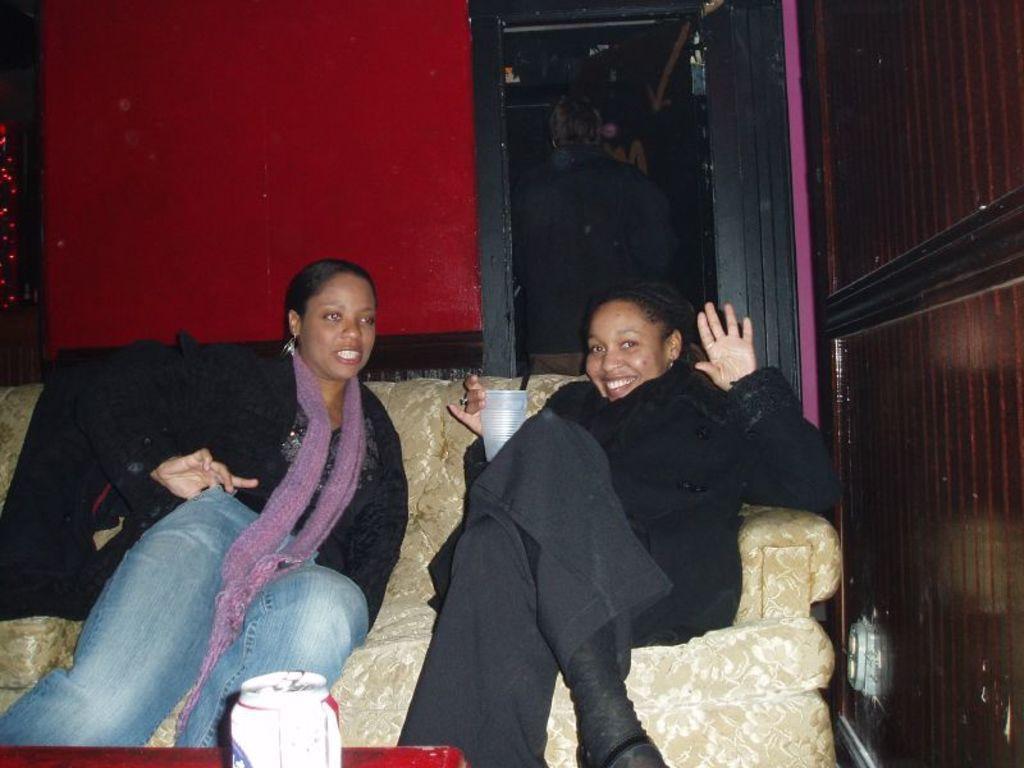Please provide a concise description of this image. In this image, there are two women sitting on a couch. At the bottom of the image, I can see a tin on an object. Behind the women, I can see a person standing and there is a wall. 